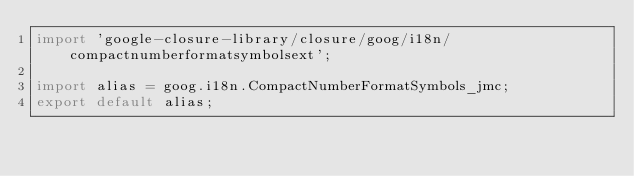Convert code to text. <code><loc_0><loc_0><loc_500><loc_500><_TypeScript_>import 'google-closure-library/closure/goog/i18n/compactnumberformatsymbolsext';

import alias = goog.i18n.CompactNumberFormatSymbols_jmc;
export default alias;
</code> 